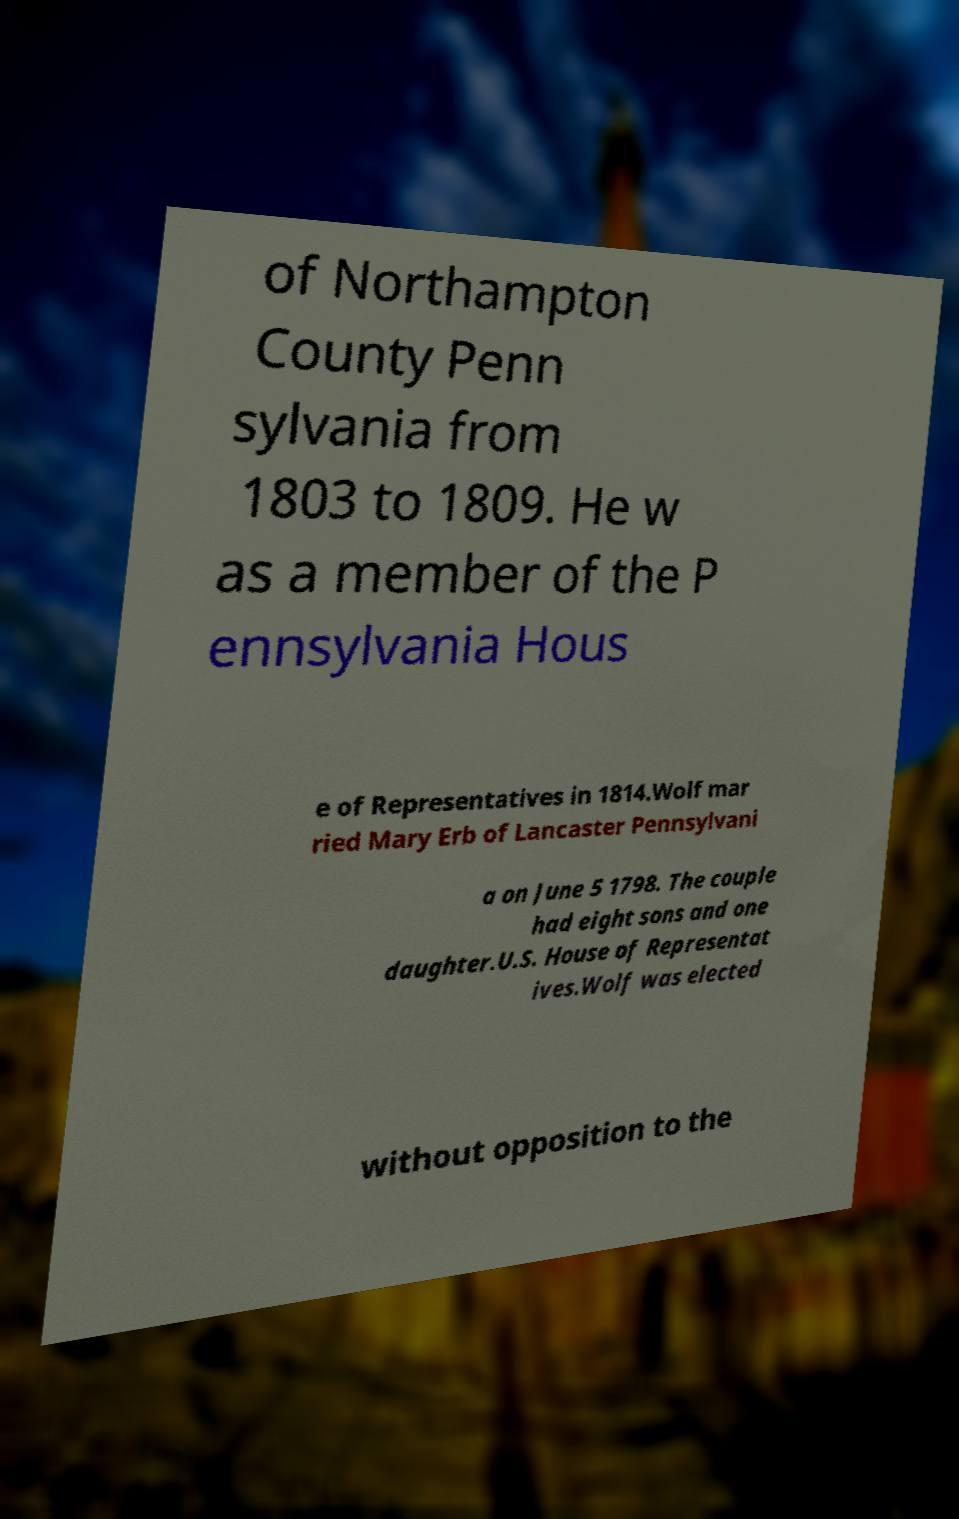Please read and relay the text visible in this image. What does it say? of Northampton County Penn sylvania from 1803 to 1809. He w as a member of the P ennsylvania Hous e of Representatives in 1814.Wolf mar ried Mary Erb of Lancaster Pennsylvani a on June 5 1798. The couple had eight sons and one daughter.U.S. House of Representat ives.Wolf was elected without opposition to the 